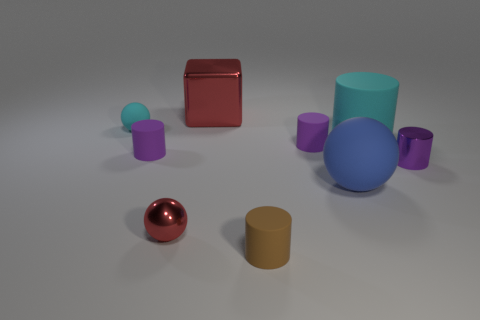Subtract all brown matte cylinders. How many cylinders are left? 4 Subtract 0 green cylinders. How many objects are left? 9 Subtract all cylinders. How many objects are left? 4 Subtract 1 cubes. How many cubes are left? 0 Subtract all yellow cylinders. Subtract all red spheres. How many cylinders are left? 5 Subtract all yellow blocks. How many yellow balls are left? 0 Subtract all cyan rubber spheres. Subtract all large blue matte things. How many objects are left? 7 Add 7 blue balls. How many blue balls are left? 8 Add 3 big blue spheres. How many big blue spheres exist? 4 Add 1 tiny cylinders. How many objects exist? 10 